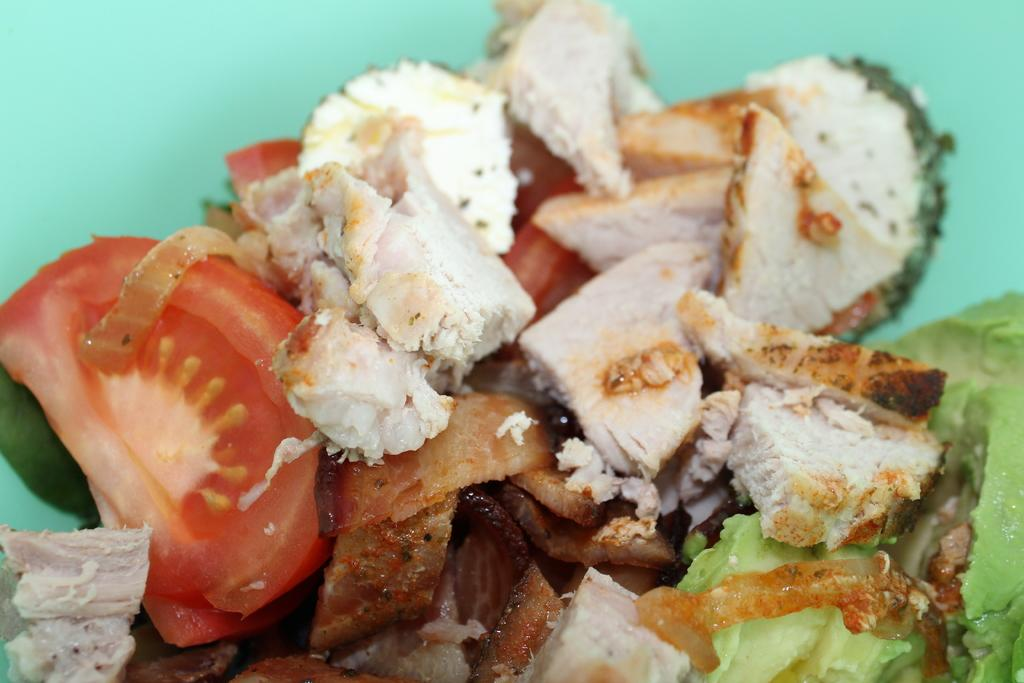What type of food items can be seen in the image? There are vegetable pieces in the image, including a tomato and cabbage. Can you describe the color of the tomato in the image? The tomato in the image is red. What is the background color in the image? The background of the image is green. How does the loaf of bread feel the thrill of the snow in the image? There is no loaf of bread or snow present in the image; it features vegetable pieces and a green background. 